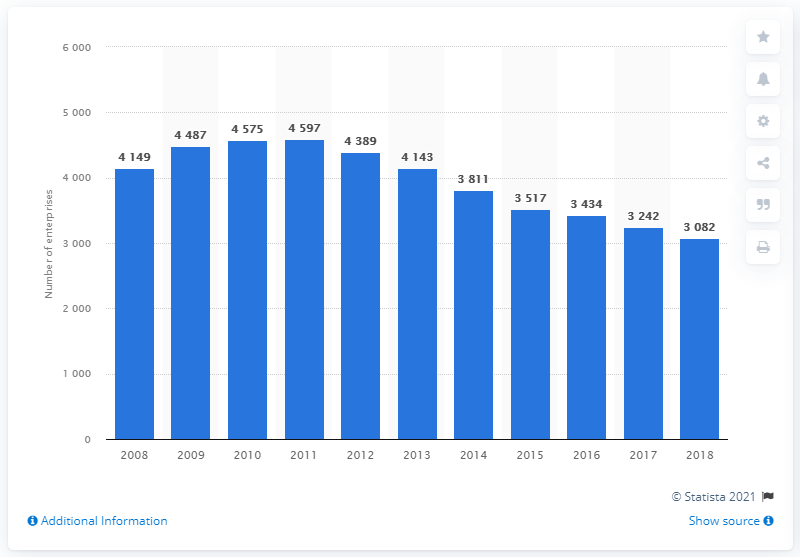Point out several critical features in this image. Since 2011, the number of newspapers and stationery stores in the UK has declined. 